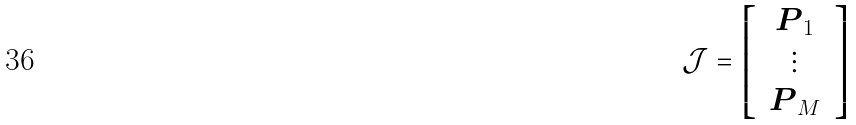Convert formula to latex. <formula><loc_0><loc_0><loc_500><loc_500>\mathcal { J } = \left [ \, \begin{array} { c } \boldsymbol P _ { 1 } \\ \vdots \\ \boldsymbol P _ { M } \end{array} \, \right ]</formula> 